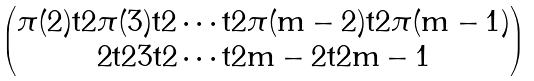<formula> <loc_0><loc_0><loc_500><loc_500>\begin{pmatrix} \pi ( 2 ) \tt t { 2 } \pi ( 3 ) \tt t { 2 } \cdots \tt t { 2 } \pi ( m - 2 ) \tt t { 2 } \pi ( m - 1 ) \\ 2 \tt t { 2 } 3 \tt t { 2 } \cdots \tt t { 2 } m - 2 \tt t { 2 } m - 1 \end{pmatrix}</formula> 